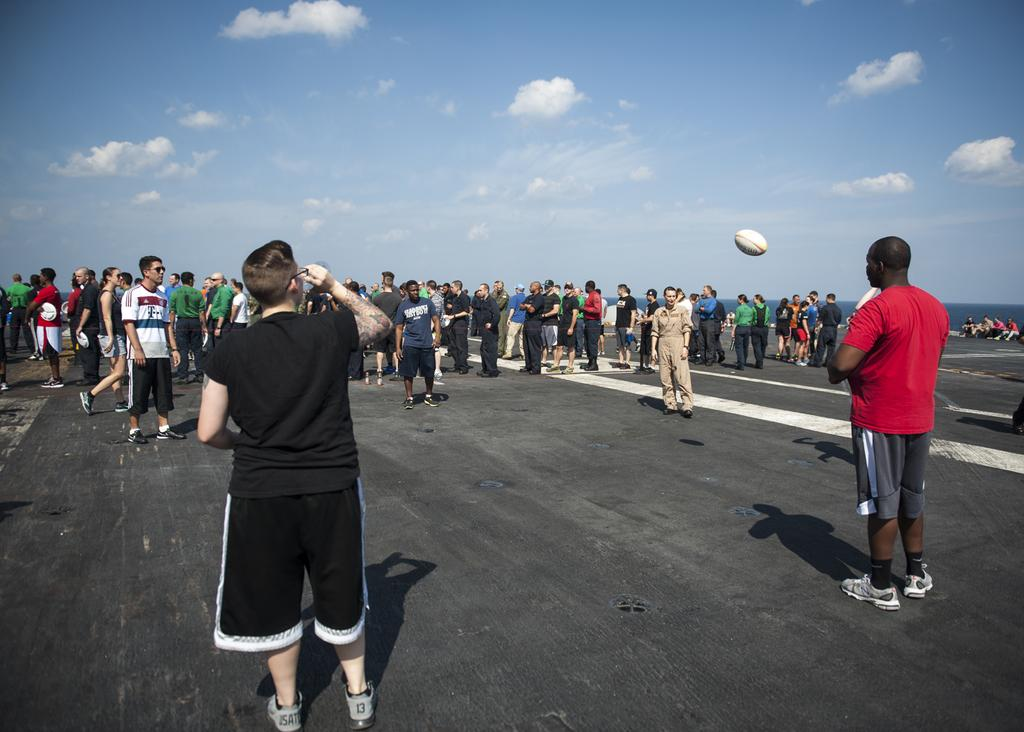What are the men in the image doing? The men are standing on a sheet in the image. What are the boys in front doing? The boys are standing and playing rugby in the image. What can be seen in the background of the image? The sky is visible in the image. What is the condition of the sky in the image? Clouds are present in the sky. How many eyes can be seen on the rugby ball in the image? There are no eyes visible on the rugby ball in the image, as it is a sports ball and does not have eyes. 